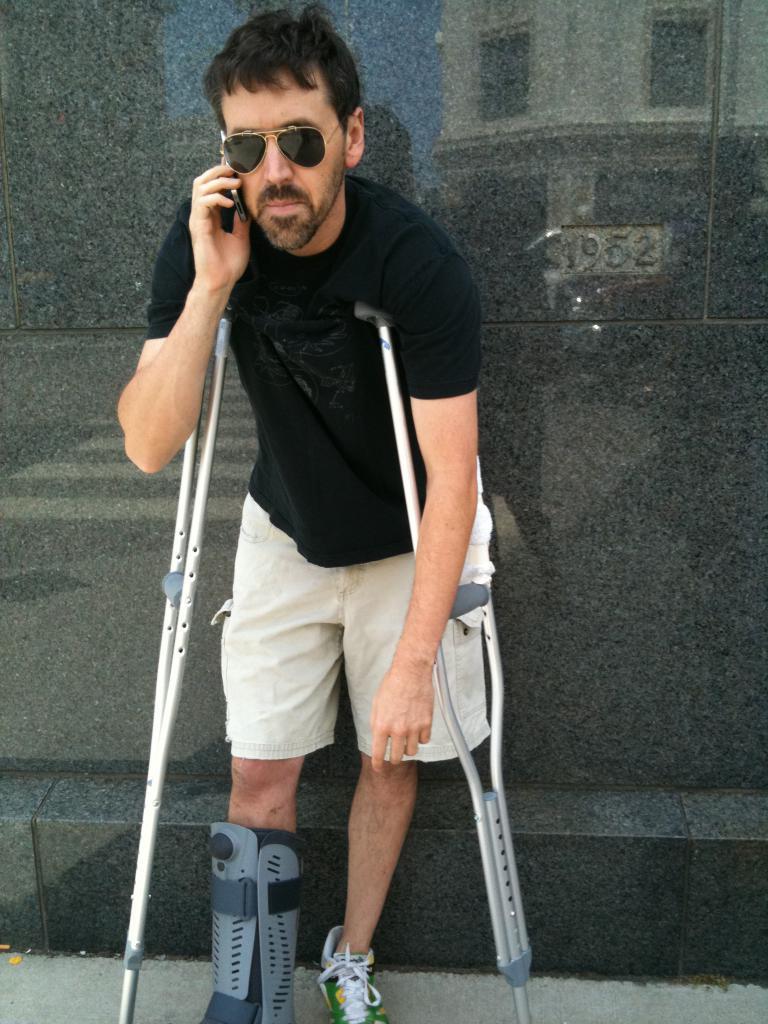In one or two sentences, can you explain what this image depicts? This person holding a mobile near his ear and wore goggles. These are support walking stands. 